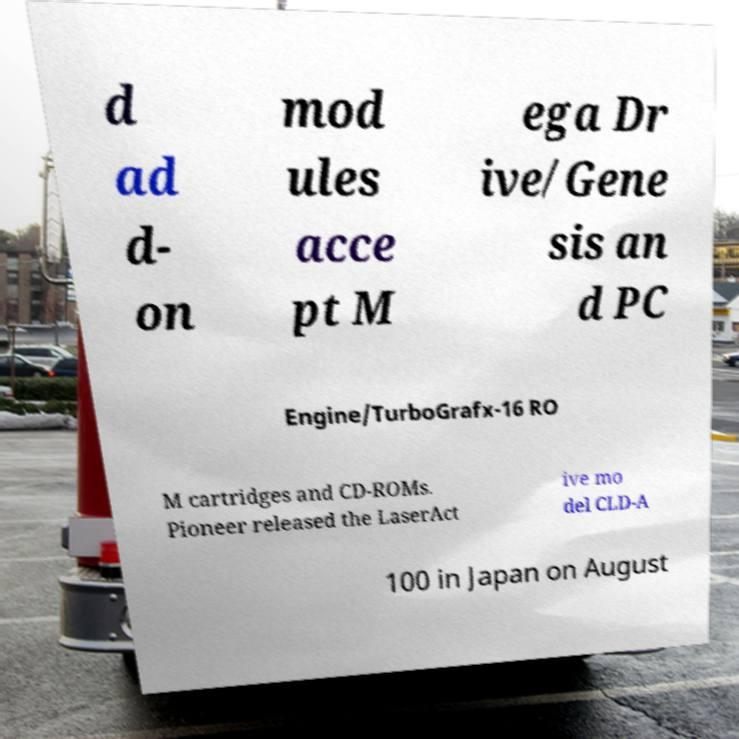What messages or text are displayed in this image? I need them in a readable, typed format. d ad d- on mod ules acce pt M ega Dr ive/Gene sis an d PC Engine/TurboGrafx-16 RO M cartridges and CD-ROMs. Pioneer released the LaserAct ive mo del CLD-A 100 in Japan on August 